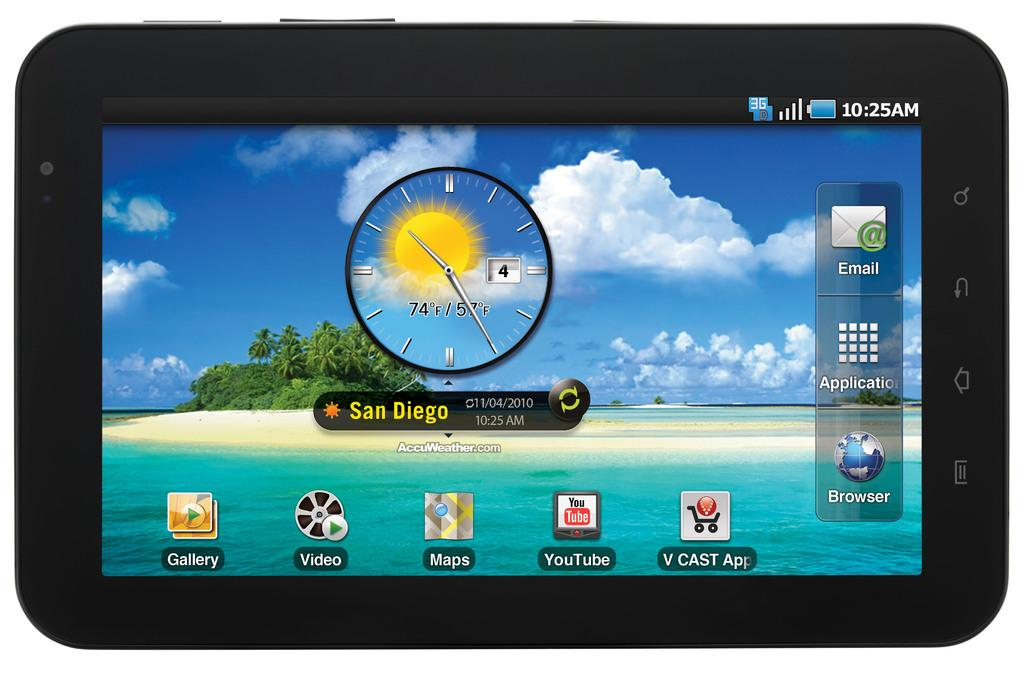<image>
Describe the image concisely. Screen that says the time and temperature for San Diego. 